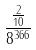<formula> <loc_0><loc_0><loc_500><loc_500>\frac { \frac { 2 } { 1 0 } } { 8 ^ { 3 6 6 } }</formula> 